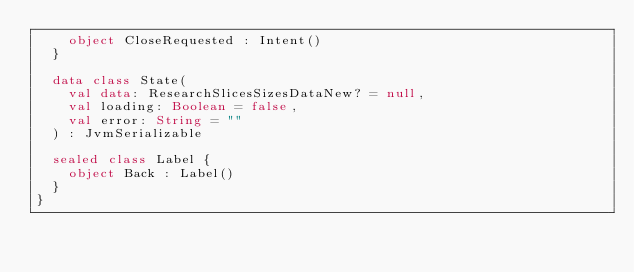Convert code to text. <code><loc_0><loc_0><loc_500><loc_500><_Kotlin_>    object CloseRequested : Intent()
  }

  data class State(
    val data: ResearchSlicesSizesDataNew? = null,
    val loading: Boolean = false,
    val error: String = ""
  ) : JvmSerializable

  sealed class Label {
    object Back : Label()
  }
}
</code> 